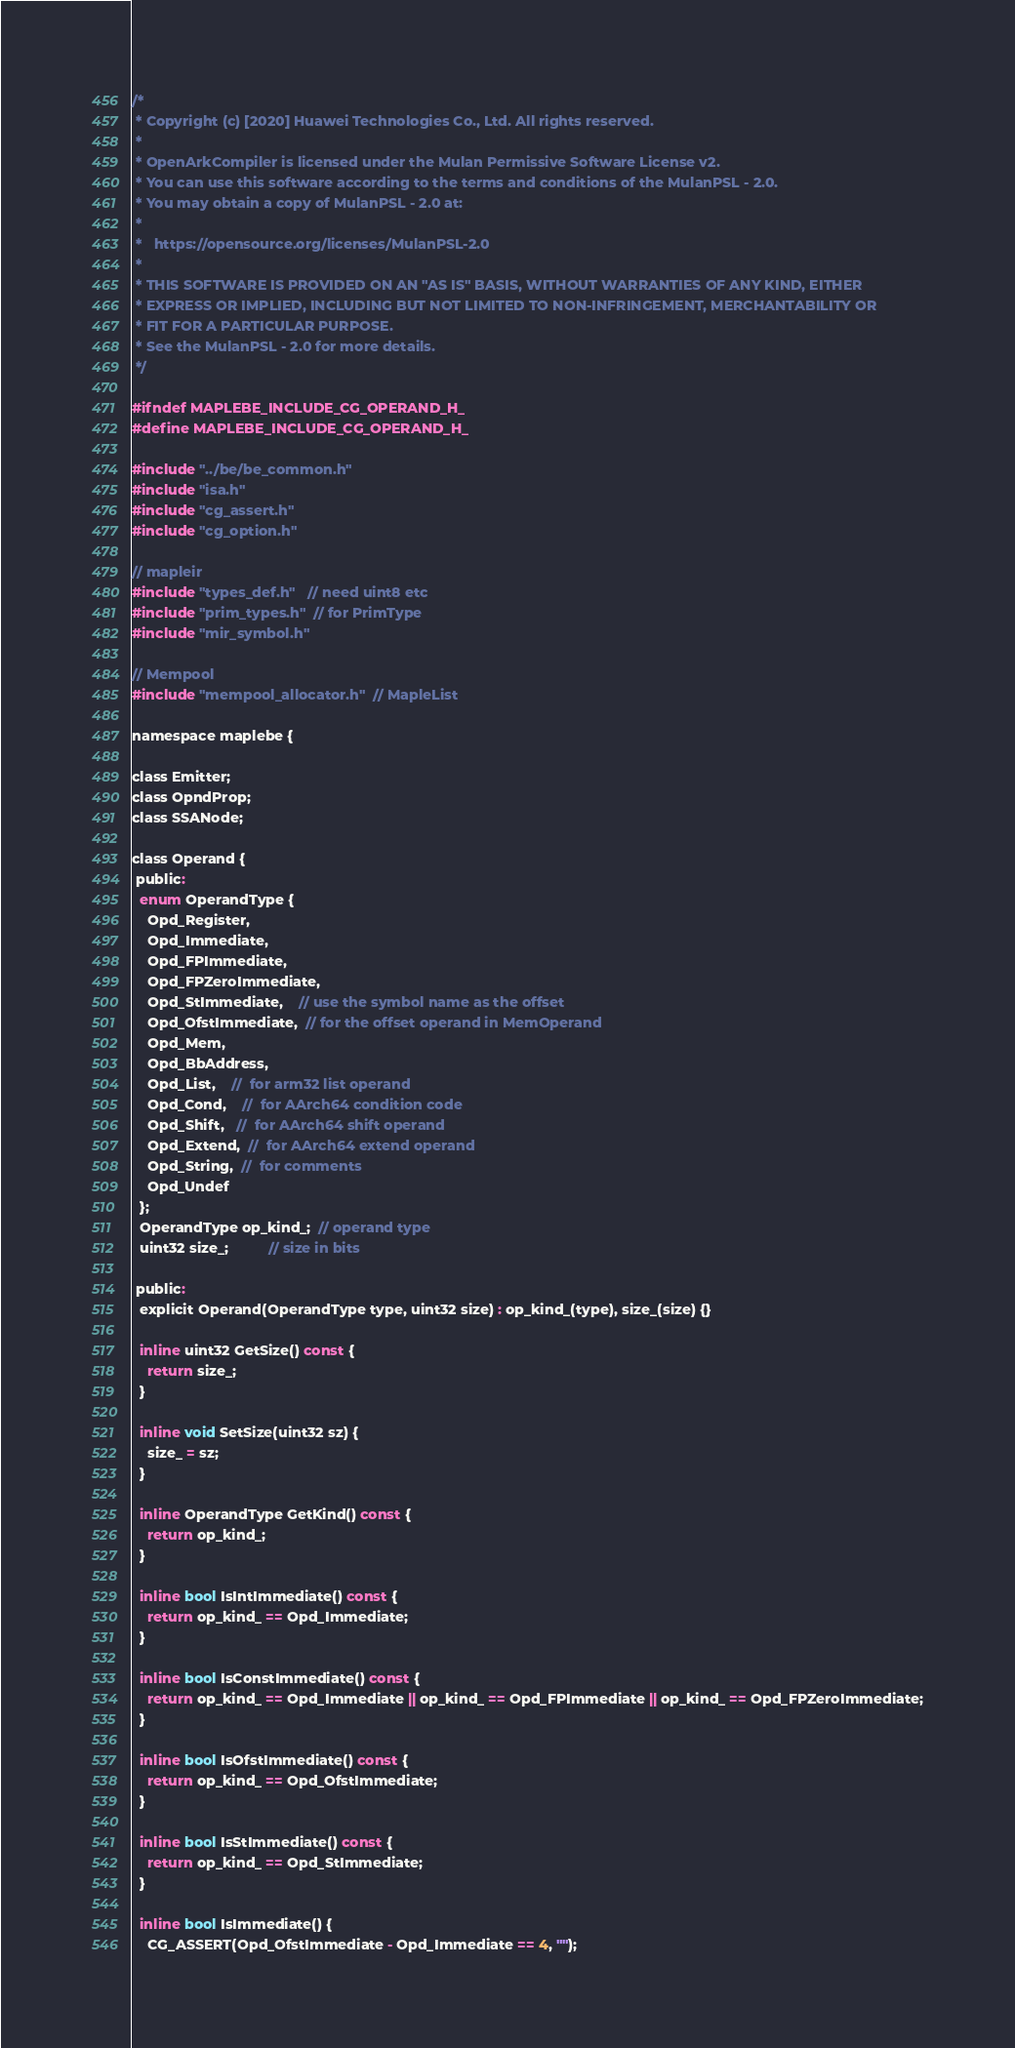Convert code to text. <code><loc_0><loc_0><loc_500><loc_500><_C_>/*
 * Copyright (c) [2020] Huawei Technologies Co., Ltd. All rights reserved.
 *
 * OpenArkCompiler is licensed under the Mulan Permissive Software License v2.
 * You can use this software according to the terms and conditions of the MulanPSL - 2.0.
 * You may obtain a copy of MulanPSL - 2.0 at:
 *
 *   https://opensource.org/licenses/MulanPSL-2.0
 *
 * THIS SOFTWARE IS PROVIDED ON AN "AS IS" BASIS, WITHOUT WARRANTIES OF ANY KIND, EITHER
 * EXPRESS OR IMPLIED, INCLUDING BUT NOT LIMITED TO NON-INFRINGEMENT, MERCHANTABILITY OR
 * FIT FOR A PARTICULAR PURPOSE.
 * See the MulanPSL - 2.0 for more details.
 */

#ifndef MAPLEBE_INCLUDE_CG_OPERAND_H_
#define MAPLEBE_INCLUDE_CG_OPERAND_H_

#include "../be/be_common.h"
#include "isa.h"
#include "cg_assert.h"
#include "cg_option.h"

// mapleir
#include "types_def.h"   // need uint8 etc
#include "prim_types.h"  // for PrimType
#include "mir_symbol.h"

// Mempool
#include "mempool_allocator.h"  // MapleList

namespace maplebe {

class Emitter;
class OpndProp;
class SSANode;

class Operand {
 public:
  enum OperandType {
    Opd_Register,
    Opd_Immediate,
    Opd_FPImmediate,
    Opd_FPZeroImmediate,
    Opd_StImmediate,    // use the symbol name as the offset
    Opd_OfstImmediate,  // for the offset operand in MemOperand
    Opd_Mem,
    Opd_BbAddress,
    Opd_List,    //  for arm32 list operand
    Opd_Cond,    //  for AArch64 condition code
    Opd_Shift,   //  for AArch64 shift operand
    Opd_Extend,  //  for AArch64 extend operand
    Opd_String,  //  for comments
    Opd_Undef
  };
  OperandType op_kind_;  // operand type
  uint32 size_;          // size in bits

 public:
  explicit Operand(OperandType type, uint32 size) : op_kind_(type), size_(size) {}

  inline uint32 GetSize() const {
    return size_;
  }

  inline void SetSize(uint32 sz) {
    size_ = sz;
  }

  inline OperandType GetKind() const {
    return op_kind_;
  }

  inline bool IsIntImmediate() const {
    return op_kind_ == Opd_Immediate;
  }

  inline bool IsConstImmediate() const {
    return op_kind_ == Opd_Immediate || op_kind_ == Opd_FPImmediate || op_kind_ == Opd_FPZeroImmediate;
  }

  inline bool IsOfstImmediate() const {
    return op_kind_ == Opd_OfstImmediate;
  }

  inline bool IsStImmediate() const {
    return op_kind_ == Opd_StImmediate;
  }

  inline bool IsImmediate() {
    CG_ASSERT(Opd_OfstImmediate - Opd_Immediate == 4, "");</code> 